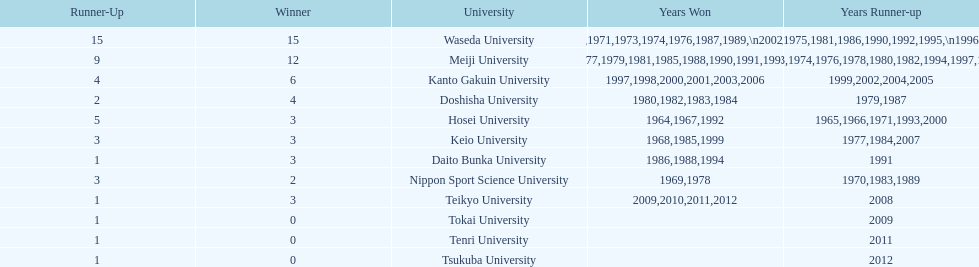Hosei won in 1964. who won the next year? Waseda University. 